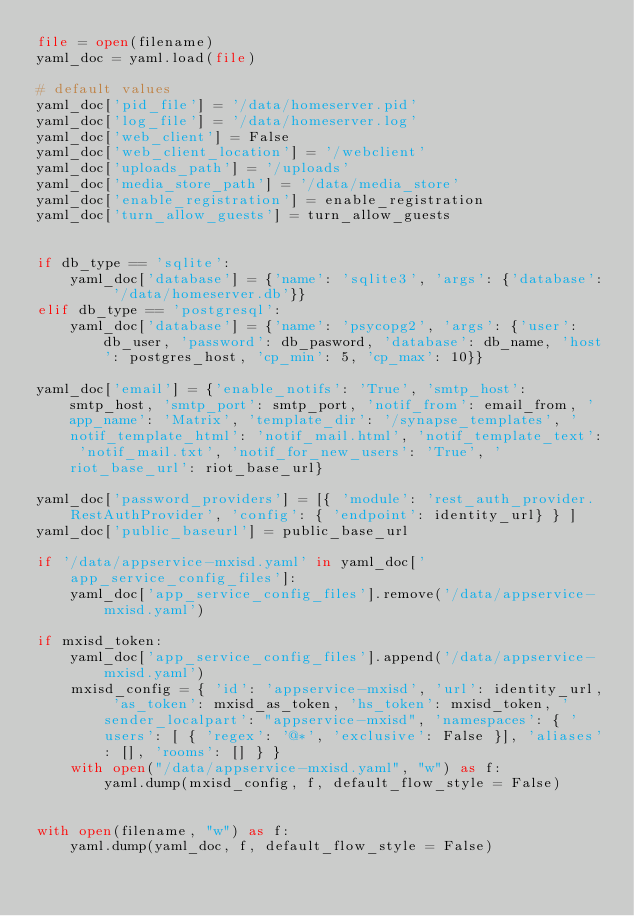<code> <loc_0><loc_0><loc_500><loc_500><_Python_>file = open(filename)
yaml_doc = yaml.load(file)

# default values
yaml_doc['pid_file'] = '/data/homeserver.pid'
yaml_doc['log_file'] = '/data/homeserver.log'
yaml_doc['web_client'] = False
yaml_doc['web_client_location'] = '/webclient'
yaml_doc['uploads_path'] = '/uploads'
yaml_doc['media_store_path'] = '/data/media_store'
yaml_doc['enable_registration'] = enable_registration
yaml_doc['turn_allow_guests'] = turn_allow_guests


if db_type == 'sqlite':
    yaml_doc['database'] = {'name': 'sqlite3', 'args': {'database': '/data/homeserver.db'}}
elif db_type == 'postgresql':
    yaml_doc['database'] = {'name': 'psycopg2', 'args': {'user': db_user, 'password': db_pasword, 'database': db_name, 'host': postgres_host, 'cp_min': 5, 'cp_max': 10}}

yaml_doc['email'] = {'enable_notifs': 'True', 'smtp_host': smtp_host, 'smtp_port': smtp_port, 'notif_from': email_from, 'app_name': 'Matrix', 'template_dir': '/synapse_templates', 'notif_template_html': 'notif_mail.html', 'notif_template_text': 'notif_mail.txt', 'notif_for_new_users': 'True', 'riot_base_url': riot_base_url}

yaml_doc['password_providers'] = [{ 'module': 'rest_auth_provider.RestAuthProvider', 'config': { 'endpoint': identity_url} } ]
yaml_doc['public_baseurl'] = public_base_url

if '/data/appservice-mxisd.yaml' in yaml_doc['app_service_config_files']:
    yaml_doc['app_service_config_files'].remove('/data/appservice-mxisd.yaml')

if mxisd_token:
    yaml_doc['app_service_config_files'].append('/data/appservice-mxisd.yaml')
    mxisd_config = { 'id': 'appservice-mxisd', 'url': identity_url, 'as_token': mxisd_as_token, 'hs_token': mxisd_token, 'sender_localpart': "appservice-mxisd", 'namespaces': { 'users': [ { 'regex': '@*', 'exclusive': False }], 'aliases': [], 'rooms': [] } }
    with open("/data/appservice-mxisd.yaml", "w") as f:
        yaml.dump(mxisd_config, f, default_flow_style = False)


with open(filename, "w") as f:
    yaml.dump(yaml_doc, f, default_flow_style = False)
</code> 